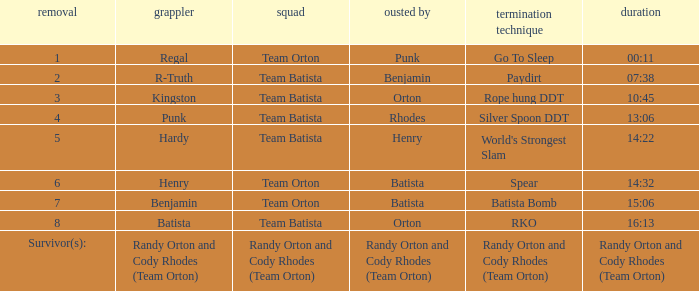Which Elimination move is listed against Team Orton, Eliminated by Batista against Elimination number 7? Batista Bomb. 